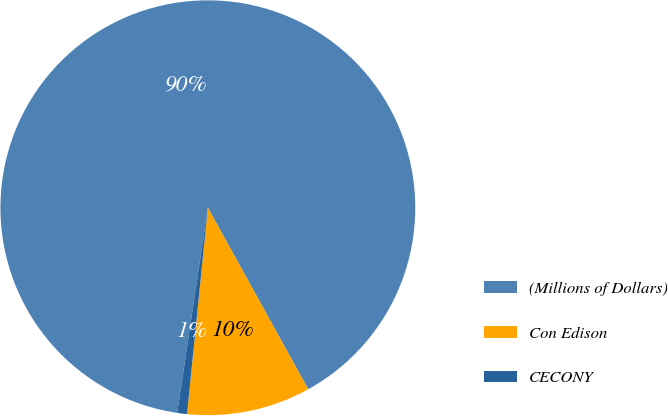Convert chart to OTSL. <chart><loc_0><loc_0><loc_500><loc_500><pie_chart><fcel>(Millions of Dollars)<fcel>Con Edison<fcel>CECONY<nl><fcel>89.6%<fcel>9.64%<fcel>0.76%<nl></chart> 